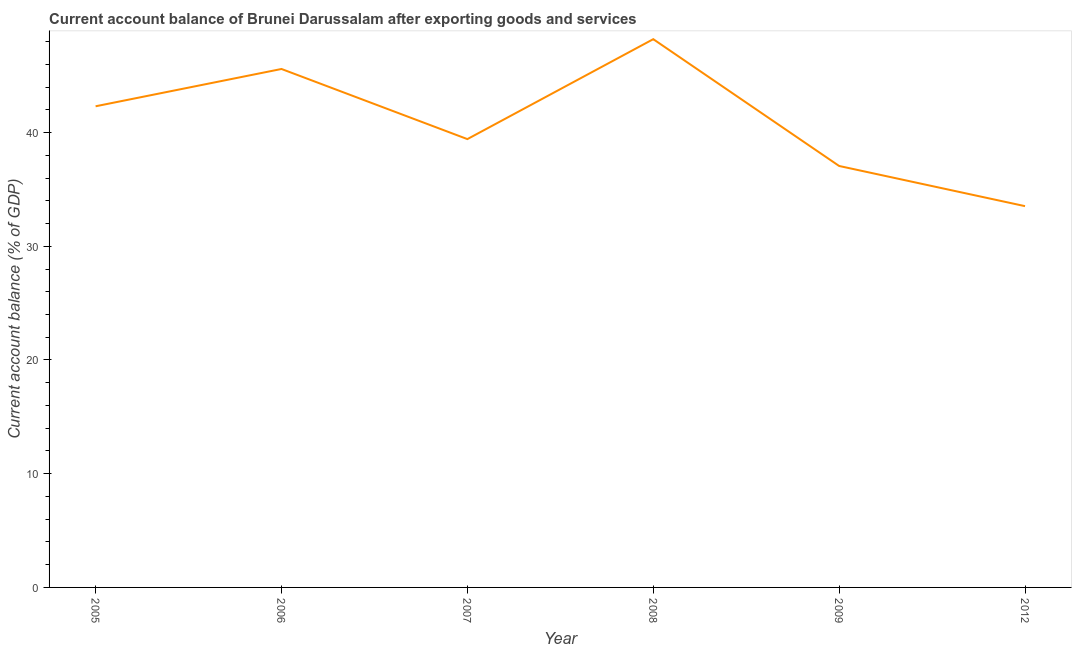What is the current account balance in 2009?
Offer a terse response. 37.06. Across all years, what is the maximum current account balance?
Keep it short and to the point. 48.21. Across all years, what is the minimum current account balance?
Offer a very short reply. 33.53. In which year was the current account balance maximum?
Offer a very short reply. 2008. In which year was the current account balance minimum?
Your answer should be very brief. 2012. What is the sum of the current account balance?
Provide a succinct answer. 246.12. What is the difference between the current account balance in 2005 and 2008?
Offer a very short reply. -5.9. What is the average current account balance per year?
Keep it short and to the point. 41.02. What is the median current account balance?
Provide a succinct answer. 40.87. In how many years, is the current account balance greater than 30 %?
Ensure brevity in your answer.  6. Do a majority of the years between 2009 and 2008 (inclusive) have current account balance greater than 12 %?
Give a very brief answer. No. What is the ratio of the current account balance in 2007 to that in 2008?
Provide a succinct answer. 0.82. What is the difference between the highest and the second highest current account balance?
Your answer should be very brief. 2.62. What is the difference between the highest and the lowest current account balance?
Your answer should be very brief. 14.68. Does the current account balance monotonically increase over the years?
Provide a short and direct response. No. How many years are there in the graph?
Give a very brief answer. 6. Does the graph contain any zero values?
Offer a very short reply. No. Does the graph contain grids?
Give a very brief answer. No. What is the title of the graph?
Keep it short and to the point. Current account balance of Brunei Darussalam after exporting goods and services. What is the label or title of the Y-axis?
Offer a very short reply. Current account balance (% of GDP). What is the Current account balance (% of GDP) in 2005?
Offer a very short reply. 42.31. What is the Current account balance (% of GDP) of 2006?
Offer a terse response. 45.59. What is the Current account balance (% of GDP) in 2007?
Offer a very short reply. 39.42. What is the Current account balance (% of GDP) of 2008?
Give a very brief answer. 48.21. What is the Current account balance (% of GDP) in 2009?
Give a very brief answer. 37.06. What is the Current account balance (% of GDP) in 2012?
Keep it short and to the point. 33.53. What is the difference between the Current account balance (% of GDP) in 2005 and 2006?
Your response must be concise. -3.28. What is the difference between the Current account balance (% of GDP) in 2005 and 2007?
Ensure brevity in your answer.  2.89. What is the difference between the Current account balance (% of GDP) in 2005 and 2008?
Your response must be concise. -5.9. What is the difference between the Current account balance (% of GDP) in 2005 and 2009?
Give a very brief answer. 5.25. What is the difference between the Current account balance (% of GDP) in 2005 and 2012?
Your answer should be very brief. 8.78. What is the difference between the Current account balance (% of GDP) in 2006 and 2007?
Offer a very short reply. 6.17. What is the difference between the Current account balance (% of GDP) in 2006 and 2008?
Provide a short and direct response. -2.62. What is the difference between the Current account balance (% of GDP) in 2006 and 2009?
Your answer should be compact. 8.53. What is the difference between the Current account balance (% of GDP) in 2006 and 2012?
Your answer should be compact. 12.06. What is the difference between the Current account balance (% of GDP) in 2007 and 2008?
Offer a very short reply. -8.79. What is the difference between the Current account balance (% of GDP) in 2007 and 2009?
Your response must be concise. 2.36. What is the difference between the Current account balance (% of GDP) in 2007 and 2012?
Make the answer very short. 5.9. What is the difference between the Current account balance (% of GDP) in 2008 and 2009?
Your response must be concise. 11.15. What is the difference between the Current account balance (% of GDP) in 2008 and 2012?
Your answer should be very brief. 14.68. What is the difference between the Current account balance (% of GDP) in 2009 and 2012?
Offer a terse response. 3.53. What is the ratio of the Current account balance (% of GDP) in 2005 to that in 2006?
Your answer should be compact. 0.93. What is the ratio of the Current account balance (% of GDP) in 2005 to that in 2007?
Keep it short and to the point. 1.07. What is the ratio of the Current account balance (% of GDP) in 2005 to that in 2008?
Offer a very short reply. 0.88. What is the ratio of the Current account balance (% of GDP) in 2005 to that in 2009?
Your answer should be compact. 1.14. What is the ratio of the Current account balance (% of GDP) in 2005 to that in 2012?
Offer a terse response. 1.26. What is the ratio of the Current account balance (% of GDP) in 2006 to that in 2007?
Your answer should be very brief. 1.16. What is the ratio of the Current account balance (% of GDP) in 2006 to that in 2008?
Your response must be concise. 0.95. What is the ratio of the Current account balance (% of GDP) in 2006 to that in 2009?
Offer a terse response. 1.23. What is the ratio of the Current account balance (% of GDP) in 2006 to that in 2012?
Ensure brevity in your answer.  1.36. What is the ratio of the Current account balance (% of GDP) in 2007 to that in 2008?
Your answer should be very brief. 0.82. What is the ratio of the Current account balance (% of GDP) in 2007 to that in 2009?
Make the answer very short. 1.06. What is the ratio of the Current account balance (% of GDP) in 2007 to that in 2012?
Keep it short and to the point. 1.18. What is the ratio of the Current account balance (% of GDP) in 2008 to that in 2009?
Offer a terse response. 1.3. What is the ratio of the Current account balance (% of GDP) in 2008 to that in 2012?
Offer a terse response. 1.44. What is the ratio of the Current account balance (% of GDP) in 2009 to that in 2012?
Provide a short and direct response. 1.1. 